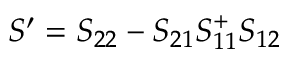<formula> <loc_0><loc_0><loc_500><loc_500>S ^ { \prime } = S _ { 2 2 } - S _ { 2 1 } S _ { 1 1 } ^ { + } S _ { 1 2 }</formula> 